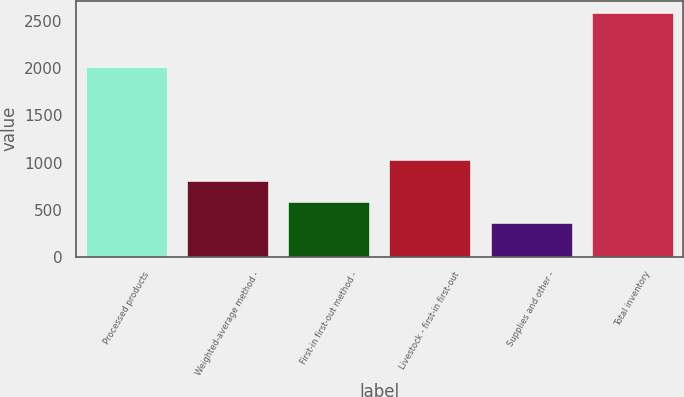Convert chart to OTSL. <chart><loc_0><loc_0><loc_500><loc_500><bar_chart><fcel>Processed products<fcel>Weighted-average method -<fcel>First-in first-out method -<fcel>Livestock - first-in first-out<fcel>Supplies and other -<fcel>Total inventory<nl><fcel>2011<fcel>807.8<fcel>585.4<fcel>1030.2<fcel>363<fcel>2587<nl></chart> 